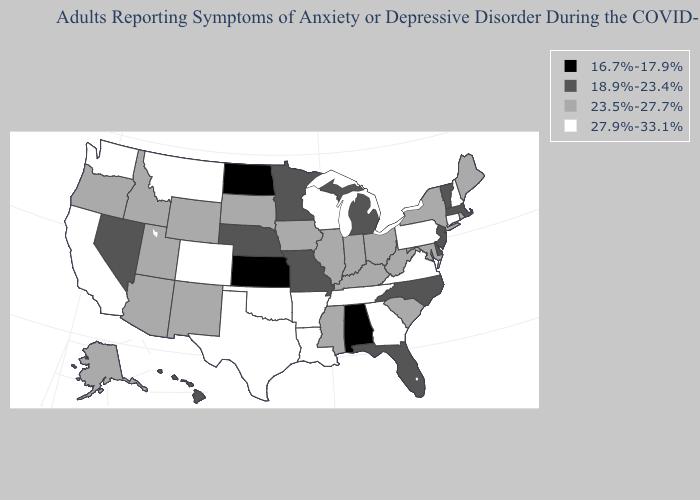What is the value of New Jersey?
Be succinct. 18.9%-23.4%. Among the states that border Colorado , which have the highest value?
Concise answer only. Oklahoma. What is the value of Minnesota?
Give a very brief answer. 18.9%-23.4%. What is the value of Arkansas?
Be succinct. 27.9%-33.1%. Does Nevada have the lowest value in the West?
Short answer required. Yes. What is the lowest value in states that border Illinois?
Write a very short answer. 18.9%-23.4%. Does Massachusetts have the same value as Michigan?
Quick response, please. Yes. What is the lowest value in states that border New Mexico?
Be succinct. 23.5%-27.7%. Name the states that have a value in the range 16.7%-17.9%?
Short answer required. Alabama, Kansas, North Dakota. What is the value of South Carolina?
Quick response, please. 23.5%-27.7%. Does New Jersey have the same value as Missouri?
Answer briefly. Yes. What is the highest value in the Northeast ?
Quick response, please. 27.9%-33.1%. Which states have the highest value in the USA?
Answer briefly. Arkansas, California, Colorado, Connecticut, Georgia, Louisiana, Montana, New Hampshire, Oklahoma, Pennsylvania, Tennessee, Texas, Virginia, Washington, Wisconsin. What is the value of Oregon?
Answer briefly. 23.5%-27.7%. What is the value of Idaho?
Answer briefly. 23.5%-27.7%. 